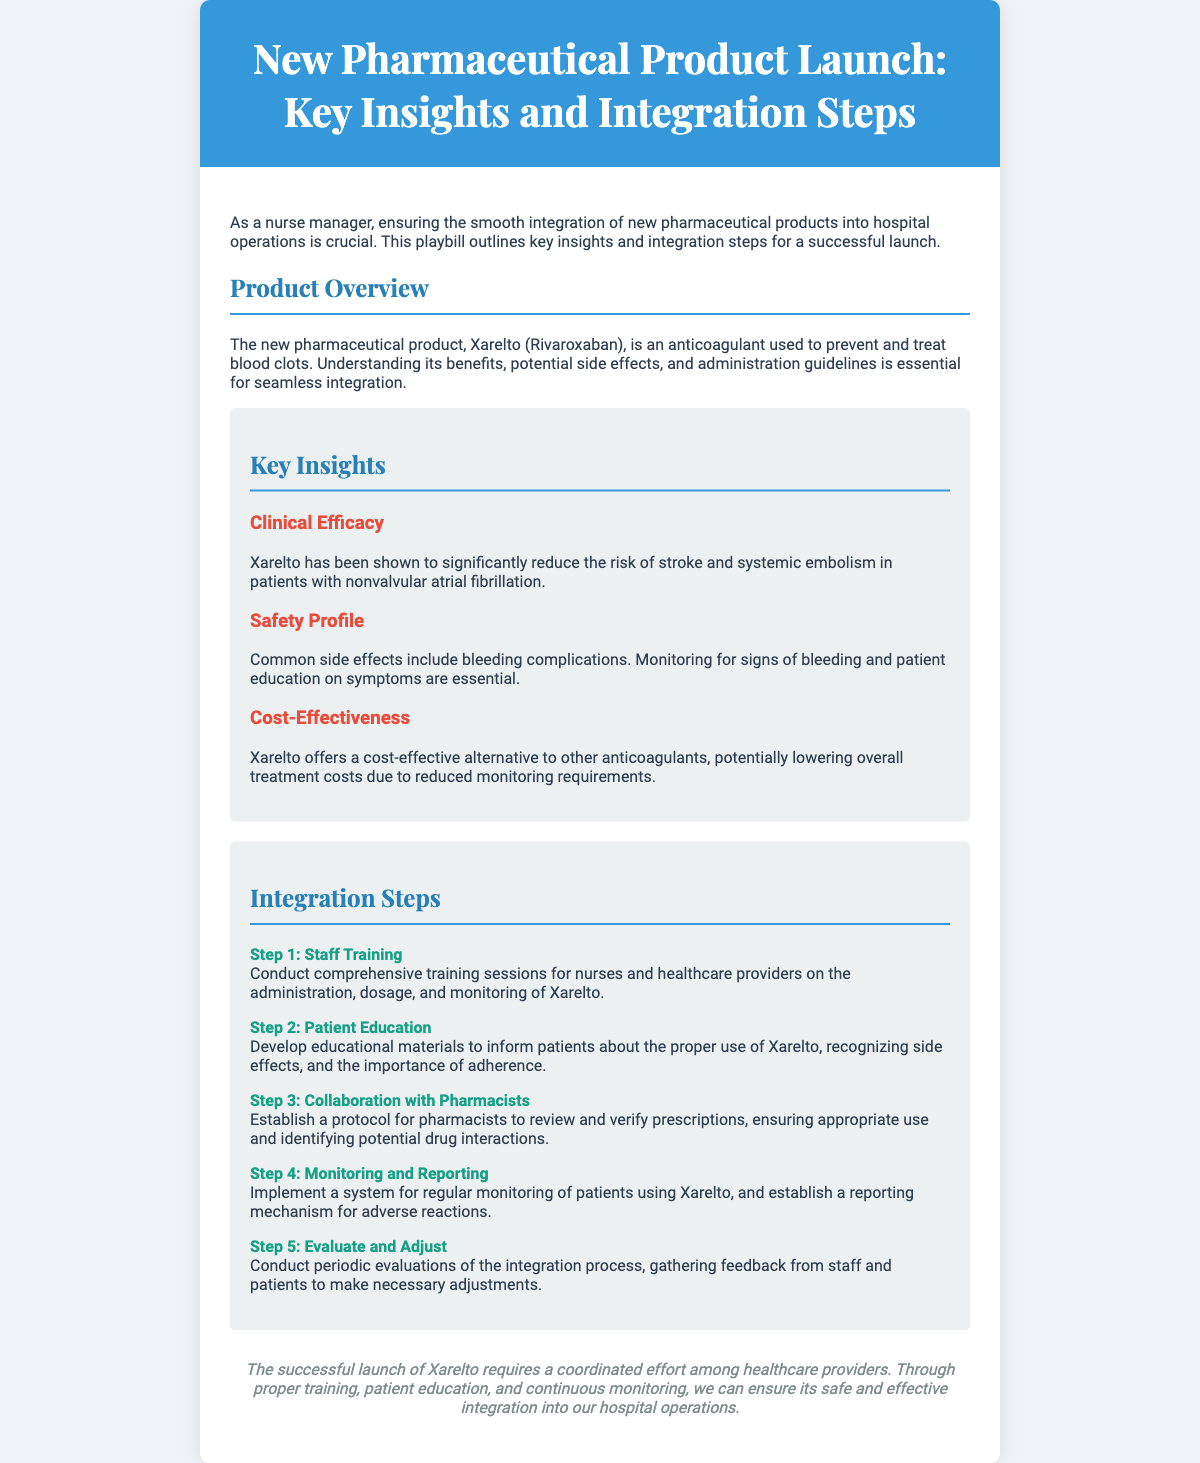What is the name of the new pharmaceutical product? The document mentions that the new pharmaceutical product is Xarelto (Rivaroxaban).
Answer: Xarelto (Rivaroxaban) What is the clinical efficacy of Xarelto? The document states that Xarelto significantly reduces the risk of stroke and systemic embolism in patients with nonvalvular atrial fibrillation.
Answer: Reduces the risk of stroke and systemic embolism What are common side effects of Xarelto? The document lists bleeding complications as common side effects of Xarelto.
Answer: Bleeding complications What is the first step in the integration process? The first step according to the document is comprehensive training sessions for nurses and healthcare providers.
Answer: Staff Training How many integration steps are outlined in the document? The document outlines five distinct integration steps for Xarelto.
Answer: Five What is one aspect of the cost-effectiveness of Xarelto? The document states that Xarelto potentially lowers overall treatment costs due to reduced monitoring requirements.
Answer: Reduced monitoring requirements What should be developed for patient education? The document emphasizes the need for educational materials to inform patients about Xarelto.
Answer: Educational materials What is the purpose of collaboration with pharmacists? The document indicates the purpose is to review and verify prescriptions for appropriate use and identify drug interactions.
Answer: To review and verify prescriptions What is the focus of the conclusion in the document? The conclusion emphasizes a coordinated effort among healthcare providers for the safe and effective integration of Xarelto.
Answer: Coordinated effort among healthcare providers 